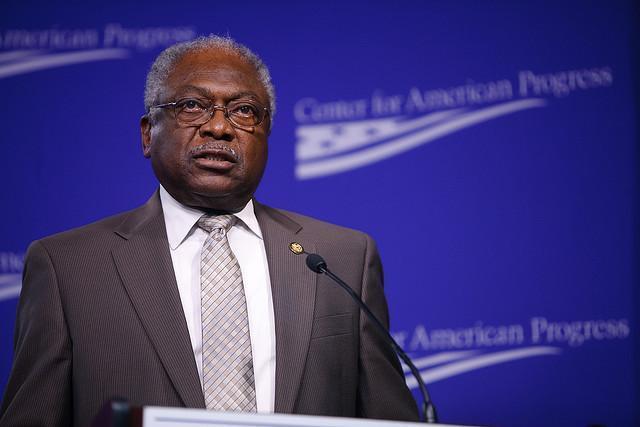How many boats are there?
Give a very brief answer. 0. 